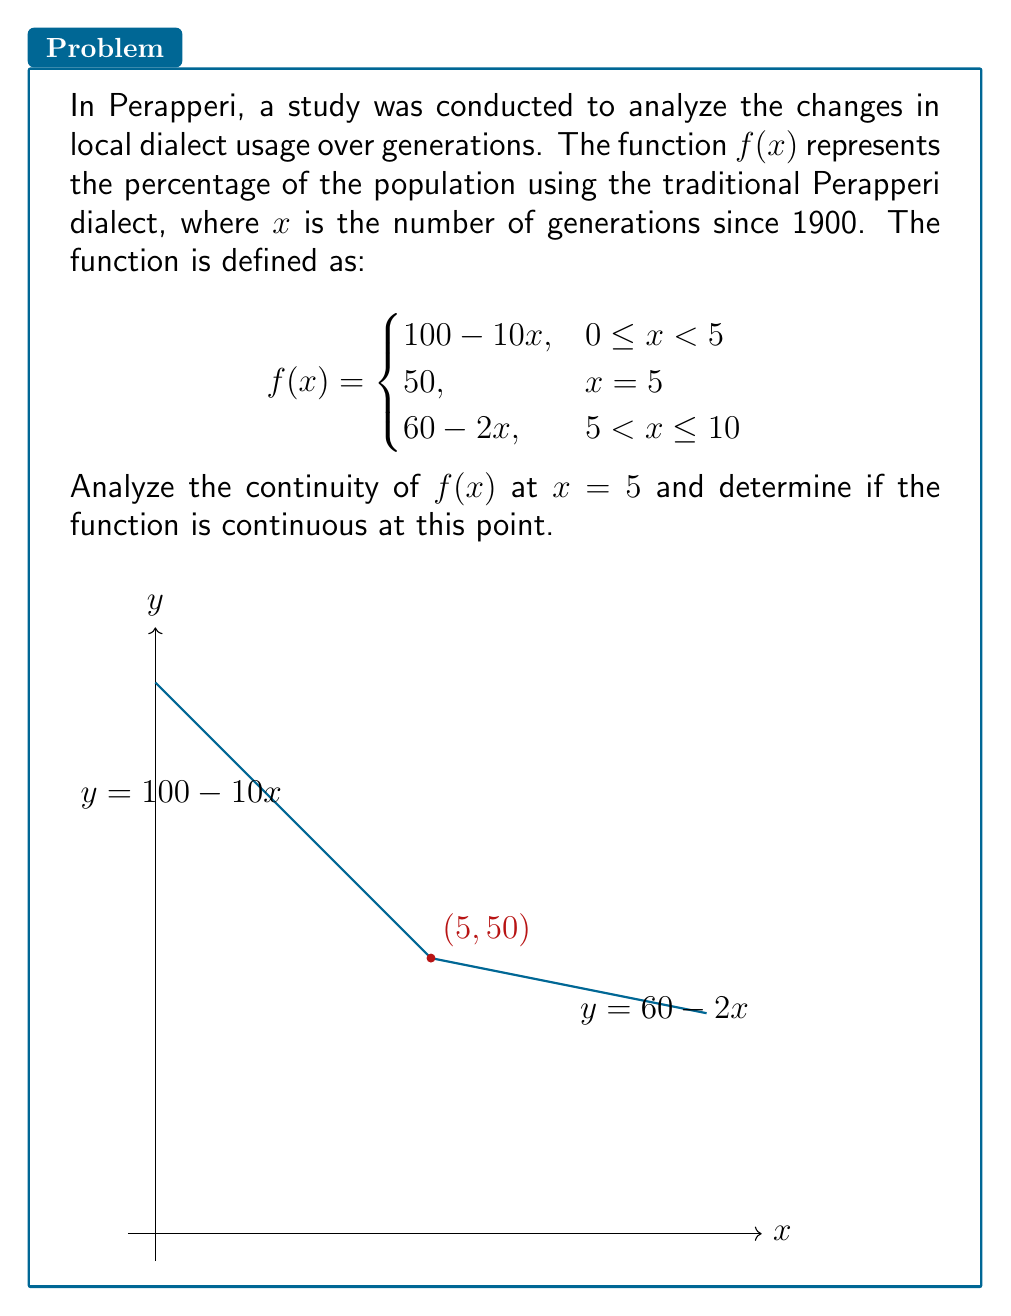Provide a solution to this math problem. To analyze the continuity of $f(x)$ at $x = 5$, we need to check three conditions:

1. $f(5)$ must exist.
2. $\lim_{x \to 5^-} f(x)$ must exist.
3. $\lim_{x \to 5^+} f(x)$ must exist.
4. All three values must be equal.

Step 1: Check if $f(5)$ exists
$f(5) = 50$ (given in the piecewise function)

Step 2: Calculate $\lim_{x \to 5^-} f(x)$
Using the left piece of the function:
$\lim_{x \to 5^-} f(x) = \lim_{x \to 5^-} (100 - 10x) = 100 - 10(5) = 50$

Step 3: Calculate $\lim_{x \to 5^+} f(x)$
Using the right piece of the function:
$\lim_{x \to 5^+} f(x) = \lim_{x \to 5^+} (60 - 2x) = 60 - 2(5) = 50$

Step 4: Compare the values
$f(5) = 50$
$\lim_{x \to 5^-} f(x) = 50$
$\lim_{x \to 5^+} f(x) = 50$

All three values are equal to 50.

Therefore, the function $f(x)$ is continuous at $x = 5$.
Answer: $f(x)$ is continuous at $x = 5$. 